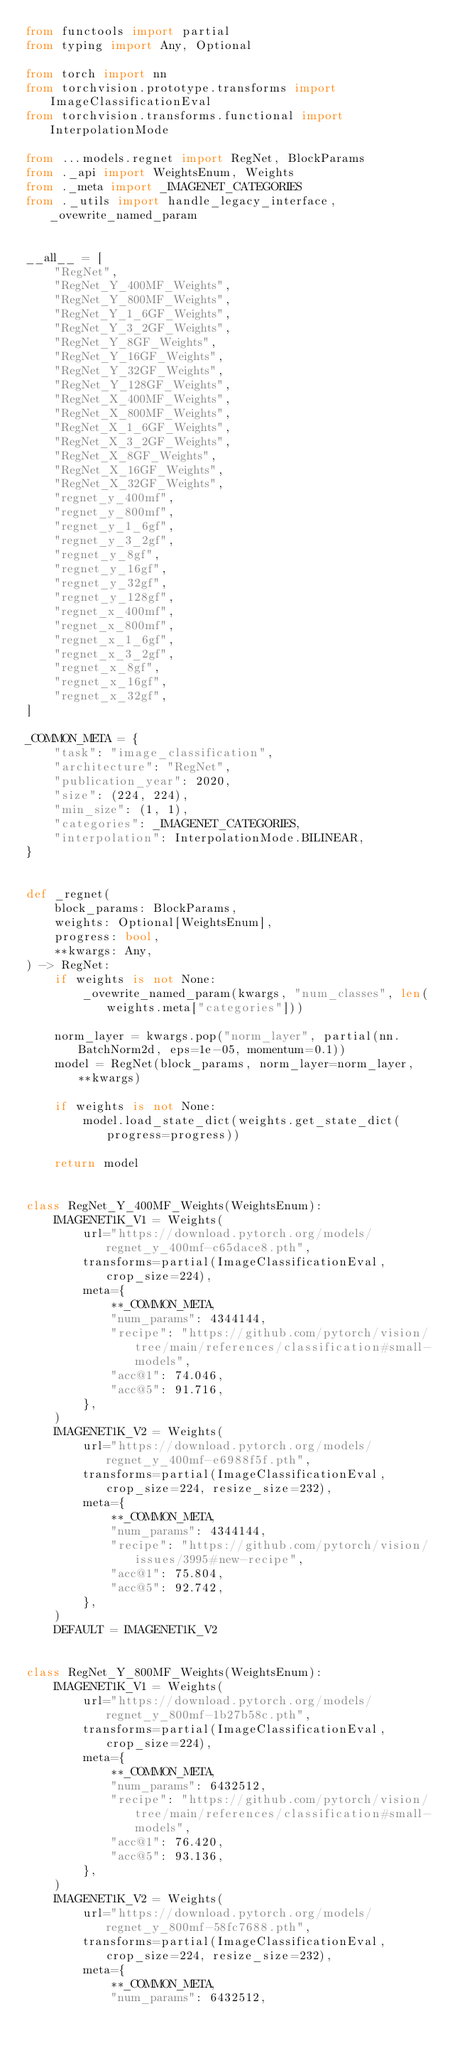<code> <loc_0><loc_0><loc_500><loc_500><_Python_>from functools import partial
from typing import Any, Optional

from torch import nn
from torchvision.prototype.transforms import ImageClassificationEval
from torchvision.transforms.functional import InterpolationMode

from ...models.regnet import RegNet, BlockParams
from ._api import WeightsEnum, Weights
from ._meta import _IMAGENET_CATEGORIES
from ._utils import handle_legacy_interface, _ovewrite_named_param


__all__ = [
    "RegNet",
    "RegNet_Y_400MF_Weights",
    "RegNet_Y_800MF_Weights",
    "RegNet_Y_1_6GF_Weights",
    "RegNet_Y_3_2GF_Weights",
    "RegNet_Y_8GF_Weights",
    "RegNet_Y_16GF_Weights",
    "RegNet_Y_32GF_Weights",
    "RegNet_Y_128GF_Weights",
    "RegNet_X_400MF_Weights",
    "RegNet_X_800MF_Weights",
    "RegNet_X_1_6GF_Weights",
    "RegNet_X_3_2GF_Weights",
    "RegNet_X_8GF_Weights",
    "RegNet_X_16GF_Weights",
    "RegNet_X_32GF_Weights",
    "regnet_y_400mf",
    "regnet_y_800mf",
    "regnet_y_1_6gf",
    "regnet_y_3_2gf",
    "regnet_y_8gf",
    "regnet_y_16gf",
    "regnet_y_32gf",
    "regnet_y_128gf",
    "regnet_x_400mf",
    "regnet_x_800mf",
    "regnet_x_1_6gf",
    "regnet_x_3_2gf",
    "regnet_x_8gf",
    "regnet_x_16gf",
    "regnet_x_32gf",
]

_COMMON_META = {
    "task": "image_classification",
    "architecture": "RegNet",
    "publication_year": 2020,
    "size": (224, 224),
    "min_size": (1, 1),
    "categories": _IMAGENET_CATEGORIES,
    "interpolation": InterpolationMode.BILINEAR,
}


def _regnet(
    block_params: BlockParams,
    weights: Optional[WeightsEnum],
    progress: bool,
    **kwargs: Any,
) -> RegNet:
    if weights is not None:
        _ovewrite_named_param(kwargs, "num_classes", len(weights.meta["categories"]))

    norm_layer = kwargs.pop("norm_layer", partial(nn.BatchNorm2d, eps=1e-05, momentum=0.1))
    model = RegNet(block_params, norm_layer=norm_layer, **kwargs)

    if weights is not None:
        model.load_state_dict(weights.get_state_dict(progress=progress))

    return model


class RegNet_Y_400MF_Weights(WeightsEnum):
    IMAGENET1K_V1 = Weights(
        url="https://download.pytorch.org/models/regnet_y_400mf-c65dace8.pth",
        transforms=partial(ImageClassificationEval, crop_size=224),
        meta={
            **_COMMON_META,
            "num_params": 4344144,
            "recipe": "https://github.com/pytorch/vision/tree/main/references/classification#small-models",
            "acc@1": 74.046,
            "acc@5": 91.716,
        },
    )
    IMAGENET1K_V2 = Weights(
        url="https://download.pytorch.org/models/regnet_y_400mf-e6988f5f.pth",
        transforms=partial(ImageClassificationEval, crop_size=224, resize_size=232),
        meta={
            **_COMMON_META,
            "num_params": 4344144,
            "recipe": "https://github.com/pytorch/vision/issues/3995#new-recipe",
            "acc@1": 75.804,
            "acc@5": 92.742,
        },
    )
    DEFAULT = IMAGENET1K_V2


class RegNet_Y_800MF_Weights(WeightsEnum):
    IMAGENET1K_V1 = Weights(
        url="https://download.pytorch.org/models/regnet_y_800mf-1b27b58c.pth",
        transforms=partial(ImageClassificationEval, crop_size=224),
        meta={
            **_COMMON_META,
            "num_params": 6432512,
            "recipe": "https://github.com/pytorch/vision/tree/main/references/classification#small-models",
            "acc@1": 76.420,
            "acc@5": 93.136,
        },
    )
    IMAGENET1K_V2 = Weights(
        url="https://download.pytorch.org/models/regnet_y_800mf-58fc7688.pth",
        transforms=partial(ImageClassificationEval, crop_size=224, resize_size=232),
        meta={
            **_COMMON_META,
            "num_params": 6432512,</code> 